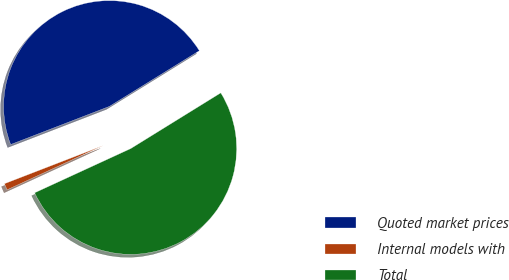Convert chart to OTSL. <chart><loc_0><loc_0><loc_500><loc_500><pie_chart><fcel>Quoted market prices<fcel>Internal models with<fcel>Total<nl><fcel>47.05%<fcel>1.0%<fcel>51.95%<nl></chart> 